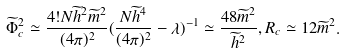Convert formula to latex. <formula><loc_0><loc_0><loc_500><loc_500>\widetilde { \Phi } _ { c } ^ { 2 } \simeq \frac { 4 ! N \widetilde { h } ^ { 2 } \widetilde { m } ^ { 2 } } { ( 4 \pi ) ^ { 2 } } ( \frac { N \widetilde { h } ^ { 4 } } { ( 4 \pi ) ^ { 2 } } - \lambda ) ^ { - 1 } \simeq \frac { 4 8 \widetilde { m } ^ { 2 } } { \widetilde { h } ^ { 2 } } , R _ { c } \simeq 1 2 \widetilde { m } ^ { 2 } .</formula> 